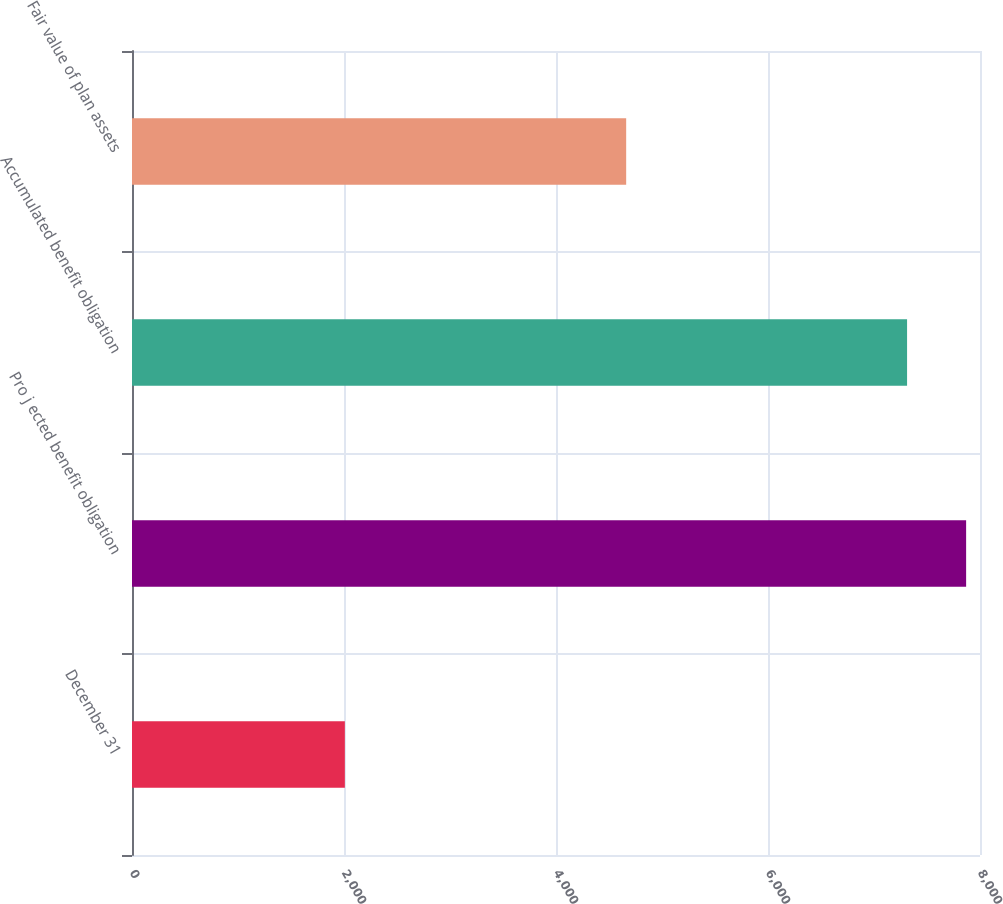Convert chart. <chart><loc_0><loc_0><loc_500><loc_500><bar_chart><fcel>December 31<fcel>Pro j ected benefit obligation<fcel>Accumulated benefit obligation<fcel>Fair value of plan assets<nl><fcel>2008<fcel>7869.1<fcel>7312<fcel>4662<nl></chart> 